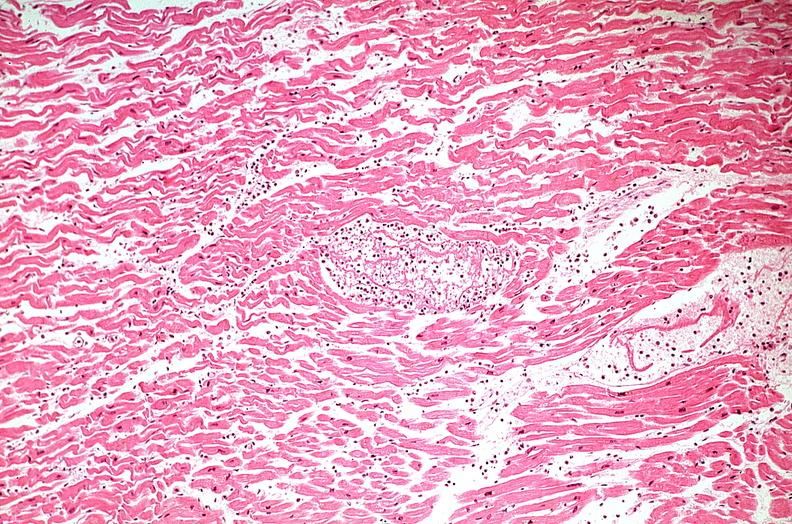does this image show heart, myocardial infarction, wavey fiber change, necrtosis, hemorrhage, and dissection?
Answer the question using a single word or phrase. Yes 